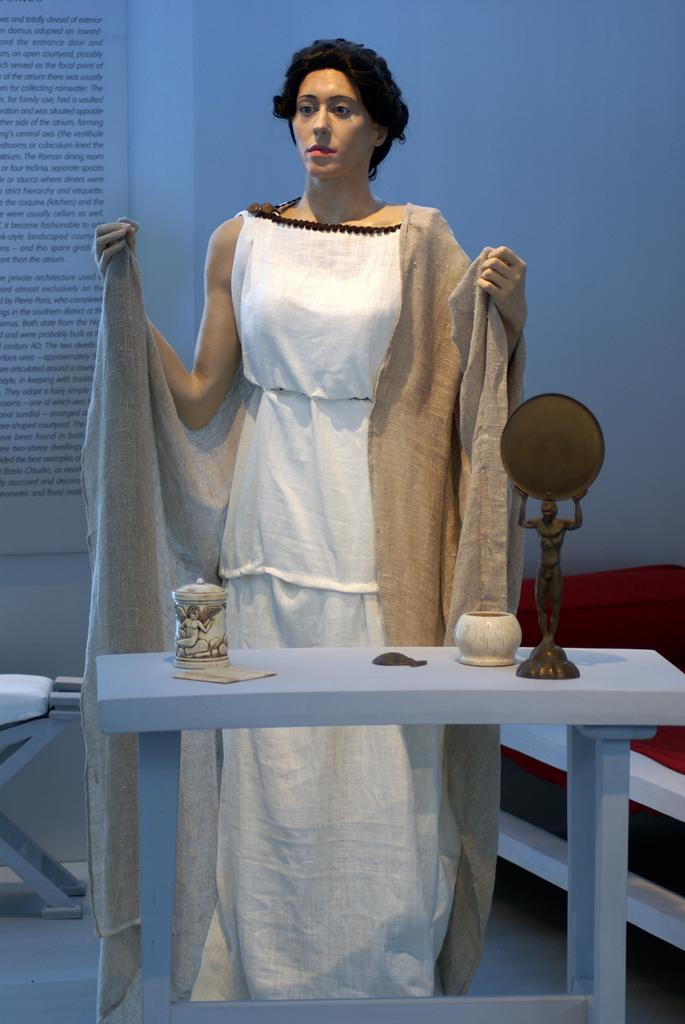What is located in the center of the image? There is a table in the middle of the image. What is on the table? There are products on the table. Who is present in the image? There is a woman behind the table. What is the woman doing? The woman is standing. What can be seen behind the woman? There is a wall behind the woman. What type of vessel is being used by the woman to communicate with her pets in the image? There is no vessel or pets present in the image. 